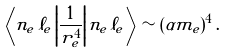Convert formula to latex. <formula><loc_0><loc_0><loc_500><loc_500>\left < n _ { e } \, \ell _ { e } \left | \frac { 1 } { r _ { e } ^ { 4 } } \right | n _ { e } \, \ell _ { e } \right > \sim ( \alpha m _ { e } ) ^ { 4 } \, .</formula> 